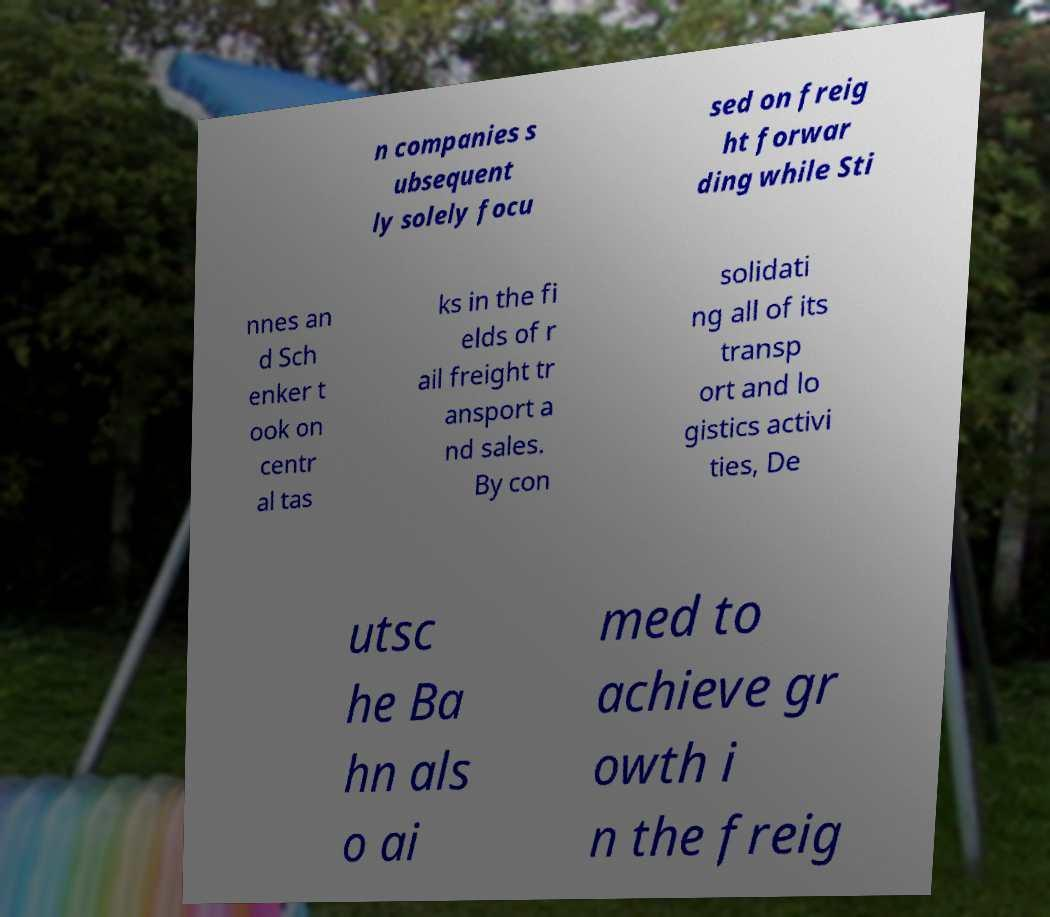Please identify and transcribe the text found in this image. n companies s ubsequent ly solely focu sed on freig ht forwar ding while Sti nnes an d Sch enker t ook on centr al tas ks in the fi elds of r ail freight tr ansport a nd sales. By con solidati ng all of its transp ort and lo gistics activi ties, De utsc he Ba hn als o ai med to achieve gr owth i n the freig 